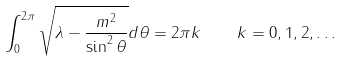<formula> <loc_0><loc_0><loc_500><loc_500>\int _ { 0 } ^ { 2 \pi } \sqrt { \lambda - \frac { m ^ { 2 } } { \sin ^ { 2 } \theta } } d \theta = 2 \pi k \quad k = 0 , 1 , 2 , \dots</formula> 